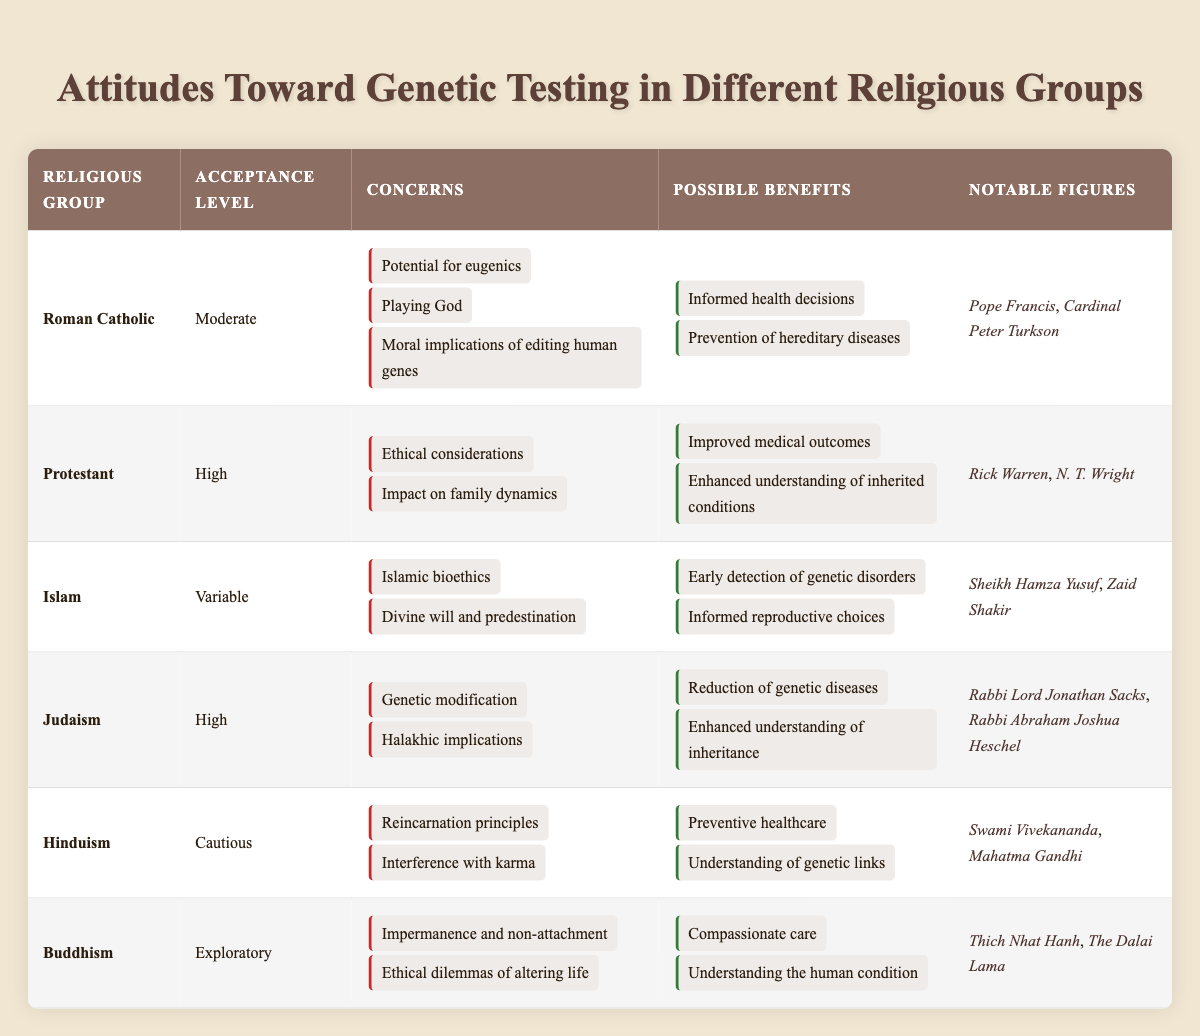What is the acceptance level of Judaism towards genetic testing? According to the table, Judaism has a "High" acceptance level towards genetic testing.
Answer: High What concerns do Roman Catholics have regarding genetic testing? The Roman Catholics have concerns about the potential for eugenics, playing God, and the moral implications of editing human genes.
Answer: Potential for eugenics, playing God, moral implications Which religious group shows a cautious attitude towards genetic testing? Hinduism is the religious group that has a "Cautious" attitude towards genetic testing as per the table.
Answer: Hinduism What are two possible benefits of genetic testing noted by Protestants? Protestants note that two possible benefits of genetic testing are improved medical outcomes and enhanced understanding of inherited conditions.
Answer: Improved medical outcomes, enhanced understanding Which religious group has notable figures such as Sheikh Hamza Yusuf? The religious group that has notable figures such as Sheikh Hamza Yusuf is Islam.
Answer: Islam How many religious groups have a high acceptance level for genetic testing? There are three religious groups with a "High" acceptance level: Protestant, Judaism, and Islam.
Answer: 2 Does Buddhism express concerns related to ethical dilemmas of altering life? Yes, Buddhism does express concerns related to ethical dilemmas of altering life according to the table.
Answer: Yes Which religious group has the most concerns listed about genetic testing? The Roman Catholic group has three concerns listed about genetic testing, which is the highest number among all groups.
Answer: Roman Catholic What is one possible benefit shared by both Judaism and Islam related to genetic testing? Both Judaism and Islam mention informed health decisions or informed reproductive choices as possible benefits of genetic testing.
Answer: Informed reproductive choices Which religious group has a notable figure known for their stance on genetic testing and is also a Dalai Lama? Buddhism has a notable figure known for their stance on genetic testing who is the Dalai Lama.
Answer: Buddhism 